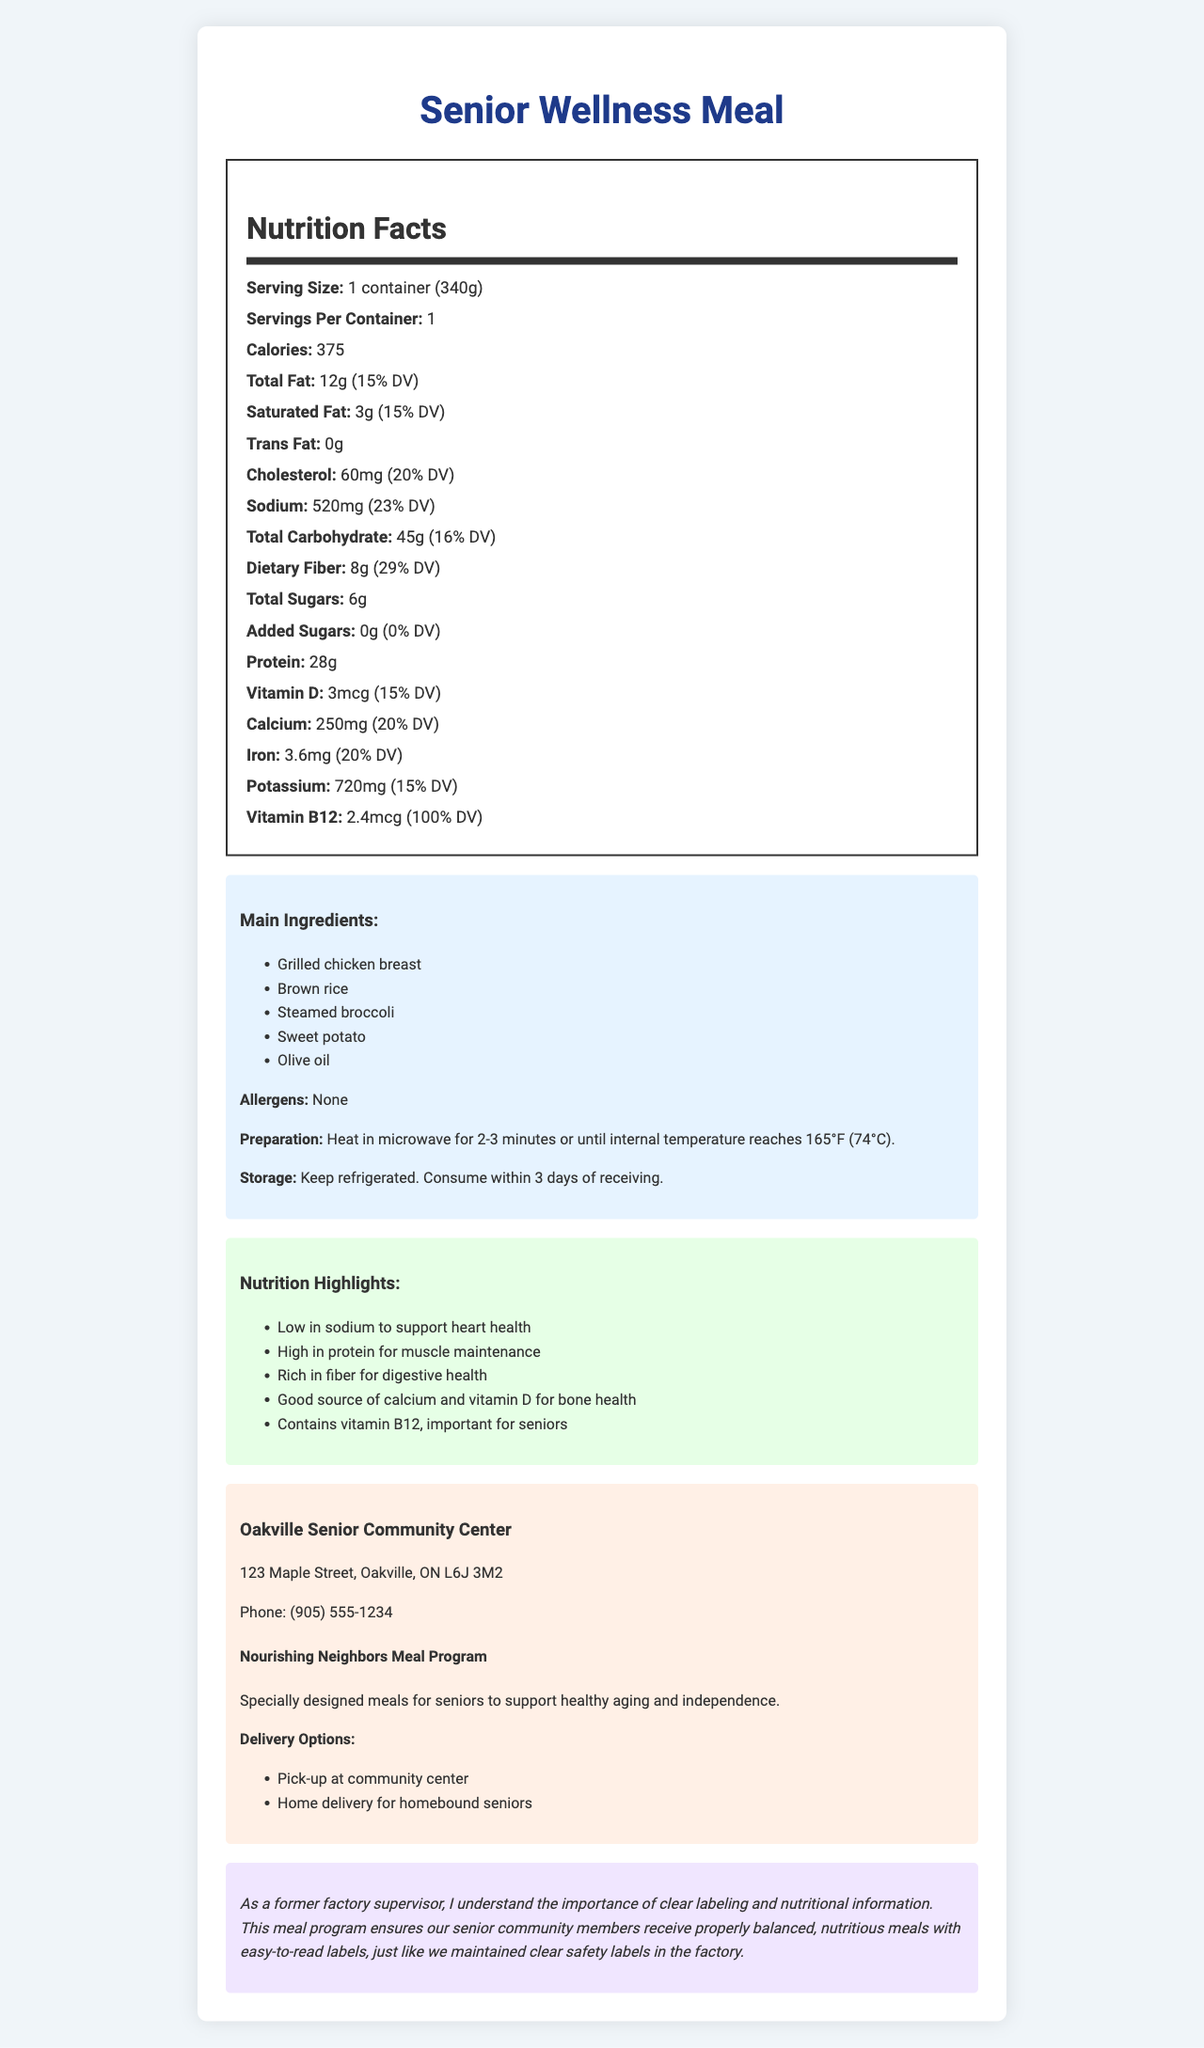what is the serving size of the "Senior Wellness Meal"? The serving size is listed as "1 container (340g)" on the document.
Answer: 1 container (340g) how many calories are in one serving of the "Senior Wellness Meal"? The document specifies that there are 375 calories per serving.
Answer: 375 what is the total amount of dietary fiber in the meal? The document states that the total dietary fiber in the meal is 8g.
Answer: 8g what is the main protein source in the meal? The ingredient list shows that "Grilled chicken breast" is a main ingredient, which is a significant source of protein.
Answer: Grilled chicken breast which nutrient has the highest daily value percentage? The document lists Vitamin B12 as having a daily value of 100%, which is the highest among the listed nutrients.
Answer: Vitamin B12 what percentage of the daily value of sodium does the meal contain? A. 10% B. 15% C. 23% D. 25% The document indicates that the sodium content is 520mg, which is 23% of the daily value.
Answer: C. 23% how long should you heat the meal in a microwave? A. 1-2 minutes B. 2-3 minutes C. 3-4 minutes D. 4-5 minutes The preparation instructions recommend heating the meal in a microwave for 2-3 minutes or until the internal temperature reaches 165°F (74°C).
Answer: B. 2-3 minutes does this meal contain any allergens? The document explicitly states "None" under the allergens section.
Answer: No does the meal contain added sugars? According to the document, the meal contains "0g" of added sugars with a daily value of "0%."
Answer: No summarize the content and purpose of the document. The document offers comprehensive data on the nutritional profile of a prepared meal targeting seniors, focusing on health benefits and community support systems to ensure balanced and nutritious eating.
Answer: The document provides detailed nutritional information for the "Senior Wellness Meal," including serving size, calorie content, and nutrient breakdown (e.g., fats, cholesterol, sodium, carbohydrates, protein, vitamins, and minerals). It lists main ingredients, allergens, preparation and storage instructions, and nutrition highlights, particularly beneficial for seniors. The document also includes community center information and details about the meal program aimed at promoting healthy aging and independence among seniors. who sponsors the meal program? The document does not provide information on the sponsor of the meal program.
Answer: Cannot be determined what is the total carbohydrate content in the meal? The document lists the total carbohydrate content as 45g, which is 16% of the daily value.
Answer: 45g where is the Oakville Senior Community Center located? The document provides the address of the community center at "123 Maple Street, Oakville, ON L6J 3M2."
Answer: 123 Maple Street, Oakville, ON L6J 3M2 how much potassium does the meal contain? The document indicates that the meal contains 720mg of potassium, which is 15% of the daily value.
Answer: 720mg 